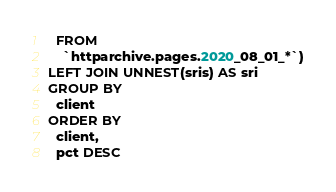<code> <loc_0><loc_0><loc_500><loc_500><_SQL_>  FROM
    `httparchive.pages.2020_08_01_*`)
LEFT JOIN UNNEST(sris) AS sri
GROUP BY
  client
ORDER BY
  client,
  pct DESC
</code> 